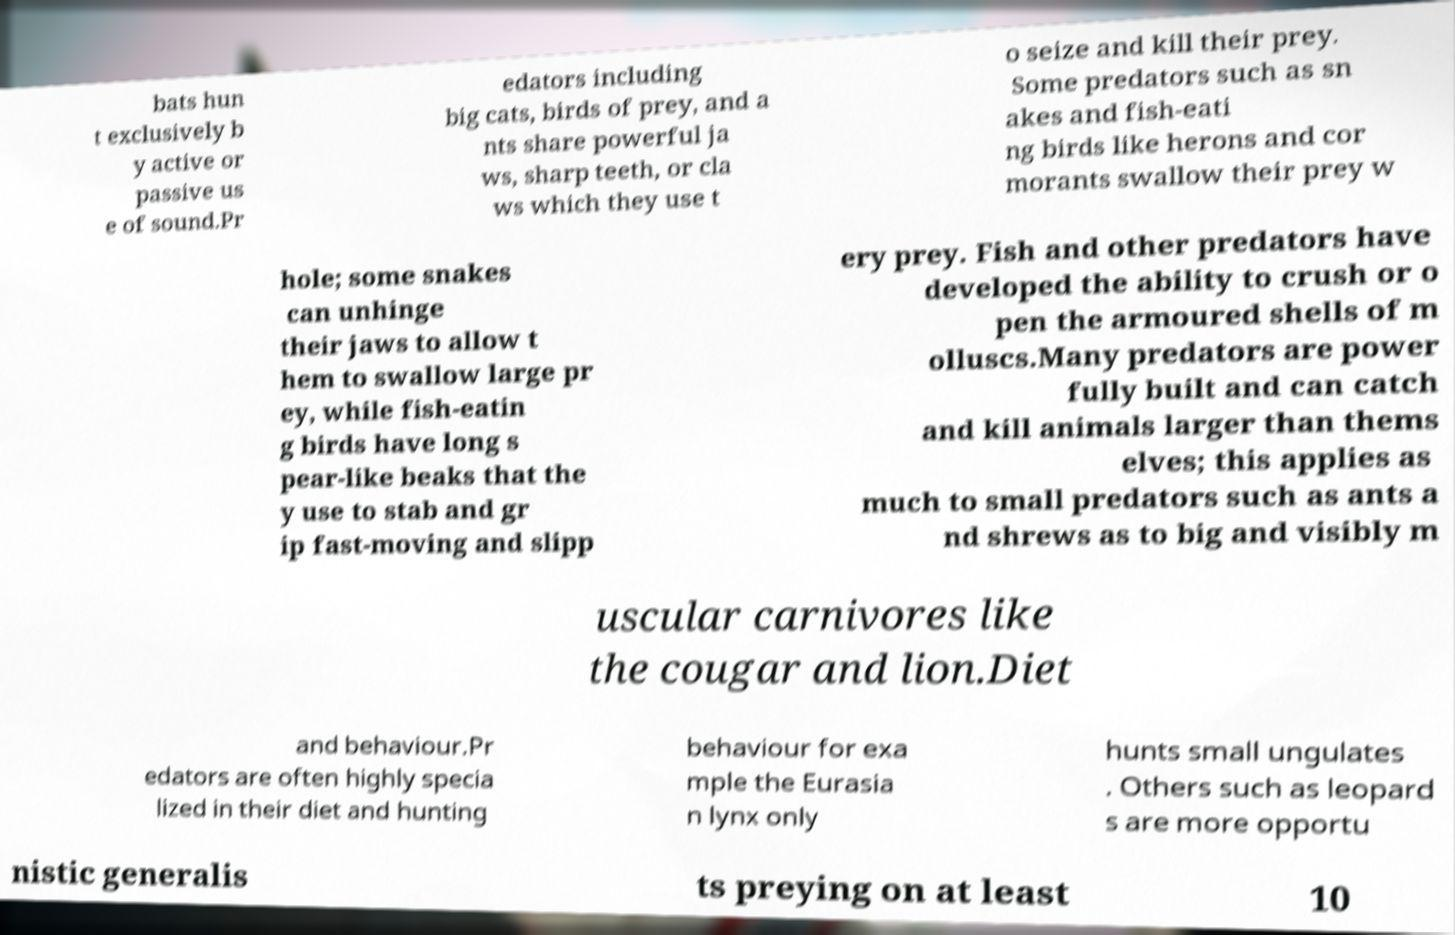Could you extract and type out the text from this image? bats hun t exclusively b y active or passive us e of sound.Pr edators including big cats, birds of prey, and a nts share powerful ja ws, sharp teeth, or cla ws which they use t o seize and kill their prey. Some predators such as sn akes and fish-eati ng birds like herons and cor morants swallow their prey w hole; some snakes can unhinge their jaws to allow t hem to swallow large pr ey, while fish-eatin g birds have long s pear-like beaks that the y use to stab and gr ip fast-moving and slipp ery prey. Fish and other predators have developed the ability to crush or o pen the armoured shells of m olluscs.Many predators are power fully built and can catch and kill animals larger than thems elves; this applies as much to small predators such as ants a nd shrews as to big and visibly m uscular carnivores like the cougar and lion.Diet and behaviour.Pr edators are often highly specia lized in their diet and hunting behaviour for exa mple the Eurasia n lynx only hunts small ungulates . Others such as leopard s are more opportu nistic generalis ts preying on at least 10 